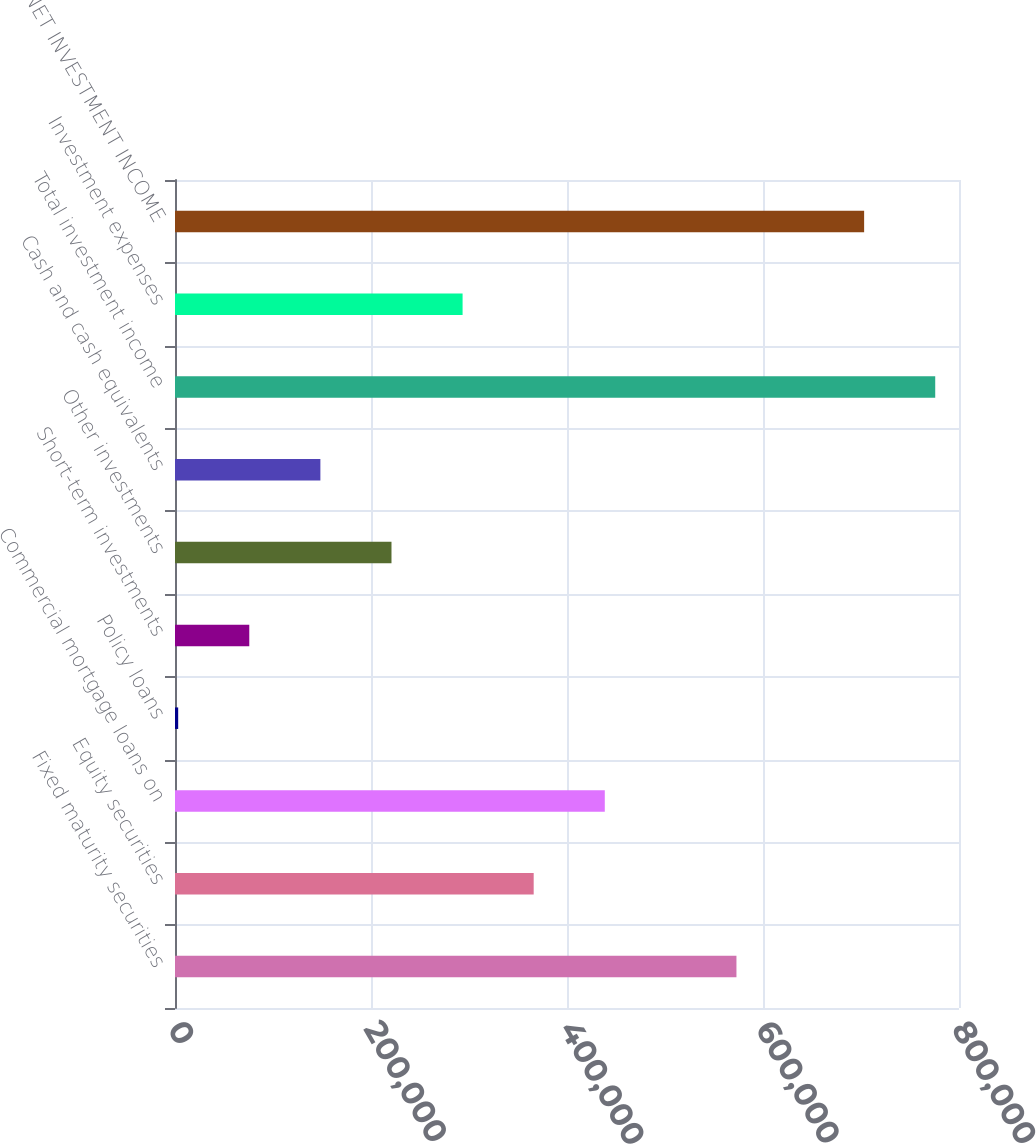Convert chart to OTSL. <chart><loc_0><loc_0><loc_500><loc_500><bar_chart><fcel>Fixed maturity securities<fcel>Equity securities<fcel>Commercial mortgage loans on<fcel>Policy loans<fcel>Short-term investments<fcel>Other investments<fcel>Cash and cash equivalents<fcel>Total investment income<fcel>Investment expenses<fcel>NET INVESTMENT INCOME<nl><fcel>572909<fcel>366009<fcel>438561<fcel>3248<fcel>75800.2<fcel>220905<fcel>148352<fcel>775742<fcel>293457<fcel>703190<nl></chart> 